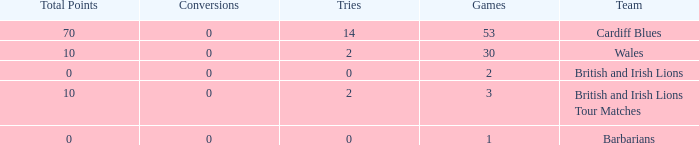Can you give me this table as a dict? {'header': ['Total Points', 'Conversions', 'Tries', 'Games', 'Team'], 'rows': [['70', '0', '14', '53', 'Cardiff Blues'], ['10', '0', '2', '30', 'Wales'], ['0', '0', '0', '2', 'British and Irish Lions'], ['10', '0', '2', '3', 'British and Irish Lions Tour Matches'], ['0', '0', '0', '1', 'Barbarians']]} What is the smallest number of tries with conversions more than 0? None. 